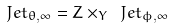<formula> <loc_0><loc_0><loc_500><loc_500>\ J e t _ { \theta , \infty } = Z \times _ { Y } \ J e t _ { \phi , \infty }</formula> 